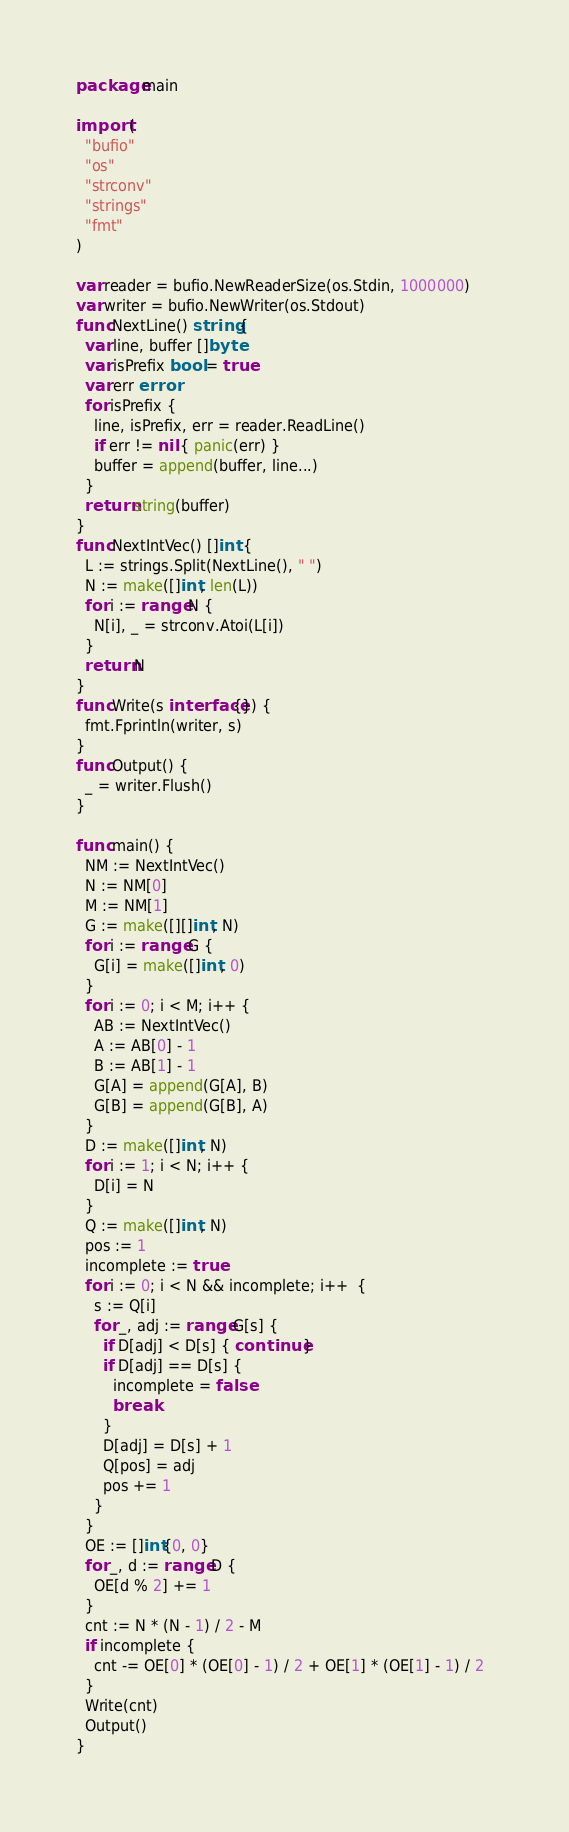<code> <loc_0><loc_0><loc_500><loc_500><_Go_>package main

import (
  "bufio"
  "os"
  "strconv"
  "strings"
  "fmt"
)

var reader = bufio.NewReaderSize(os.Stdin, 1000000)
var writer = bufio.NewWriter(os.Stdout)
func NextLine() string {
  var line, buffer []byte
  var isPrefix bool = true
  var err error
  for isPrefix {
    line, isPrefix, err = reader.ReadLine()
    if err != nil { panic(err) }
    buffer = append(buffer, line...)
  }
  return string(buffer)
}
func NextIntVec() []int {
  L := strings.Split(NextLine(), " ")
  N := make([]int, len(L))
  for i := range N {
    N[i], _ = strconv.Atoi(L[i])
  }
  return N
}
func Write(s interface{}) {
  fmt.Fprintln(writer, s)
}
func Output() {
  _ = writer.Flush()
}

func main() {
  NM := NextIntVec()
  N := NM[0]
  M := NM[1]
  G := make([][]int, N)
  for i := range G {
    G[i] = make([]int, 0)
  }
  for i := 0; i < M; i++ {
    AB := NextIntVec()
    A := AB[0] - 1
    B := AB[1] - 1
    G[A] = append(G[A], B)
    G[B] = append(G[B], A)
  }
  D := make([]int, N)
  for i := 1; i < N; i++ {
    D[i] = N
  }
  Q := make([]int, N)
  pos := 1
  incomplete := true
  for i := 0; i < N && incomplete; i++  {
    s := Q[i]
    for _, adj := range G[s] {
      if D[adj] < D[s] { continue }
      if D[adj] == D[s] {
        incomplete = false
        break
      }
      D[adj] = D[s] + 1
      Q[pos] = adj
      pos += 1
    }
  }
  OE := []int{0, 0}
  for _, d := range D {
    OE[d % 2] += 1
  }
  cnt := N * (N - 1) / 2 - M
  if incomplete {
    cnt -= OE[0] * (OE[0] - 1) / 2 + OE[1] * (OE[1] - 1) / 2  
  }
  Write(cnt)
  Output()
}</code> 